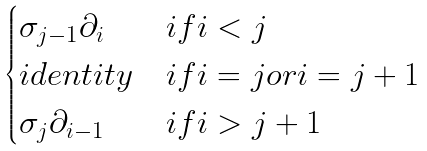<formula> <loc_0><loc_0><loc_500><loc_500>\begin{cases} \sigma _ { j - 1 } \partial _ { i } & i f i < j \\ i d e n t i t y & i f i = j o r i = j + 1 \\ \sigma _ { j } \partial _ { i - 1 } & i f i > j + 1 \end{cases}</formula> 